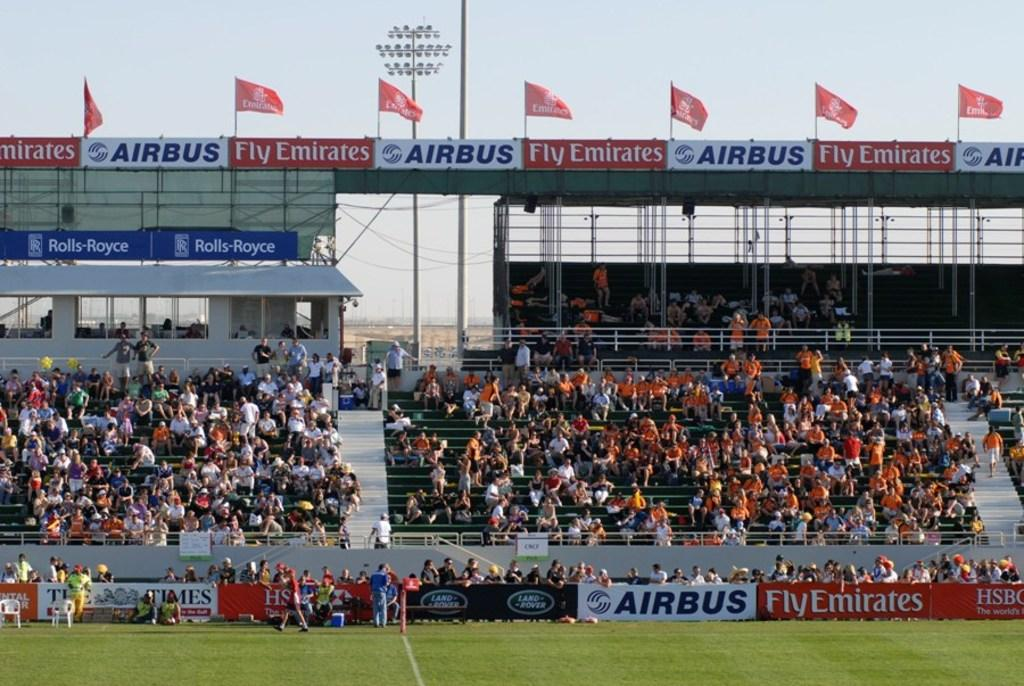<image>
Create a compact narrative representing the image presented. A crowd sitting in bleachers under a banner advertising Airbus. 